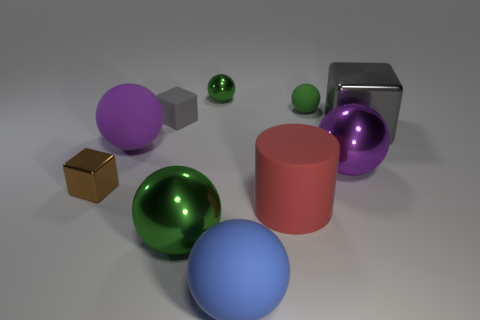The large matte object that is left of the green sphere that is in front of the gray thing to the right of the red rubber thing is what color?
Keep it short and to the point. Purple. Is the shape of the big purple matte thing that is behind the purple metal ball the same as the green metallic thing that is behind the big gray thing?
Your response must be concise. Yes. What number of tiny gray rubber objects are there?
Give a very brief answer. 1. There is a shiny cube that is the same size as the matte cylinder; what is its color?
Make the answer very short. Gray. Are the object that is left of the purple rubber ball and the big purple thing that is to the right of the red object made of the same material?
Offer a very short reply. Yes. How big is the green thing on the right side of the small shiny object right of the tiny brown thing?
Keep it short and to the point. Small. There is a small block that is to the right of the purple rubber object; what is its material?
Your answer should be compact. Rubber. What number of objects are either small balls that are to the left of the big blue ball or metal cubes that are to the left of the cylinder?
Offer a very short reply. 2. What material is the blue object that is the same shape as the large purple rubber object?
Your answer should be very brief. Rubber. There is a cube that is in front of the big gray cube; is it the same color as the large metallic sphere in front of the tiny brown metal object?
Your answer should be compact. No. 